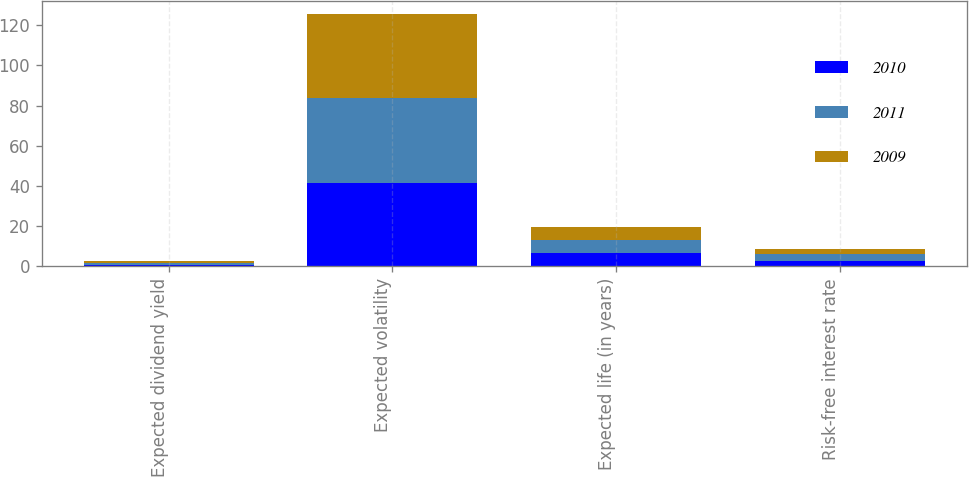Convert chart. <chart><loc_0><loc_0><loc_500><loc_500><stacked_bar_chart><ecel><fcel>Expected dividend yield<fcel>Expected volatility<fcel>Expected life (in years)<fcel>Risk-free interest rate<nl><fcel>2010<fcel>0.61<fcel>41.61<fcel>6.5<fcel>2.84<nl><fcel>2011<fcel>0.87<fcel>42.17<fcel>6.5<fcel>3.13<nl><fcel>2009<fcel>1.13<fcel>41.9<fcel>6.5<fcel>2.82<nl></chart> 